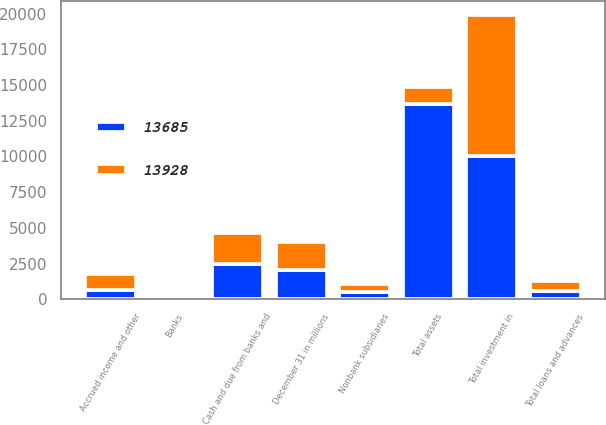Convert chart. <chart><loc_0><loc_0><loc_500><loc_500><stacked_bar_chart><ecel><fcel>December 31 in millions<fcel>Cash and due from banks and<fcel>Banks<fcel>Nonbank subsidiaries<fcel>Total loans and advances<fcel>Total investment in<fcel>Accrued income and other<fcel>Total assets<nl><fcel>13685<fcel>2013<fcel>2453<fcel>90<fcel>482<fcel>572<fcel>10049<fcel>611<fcel>13685<nl><fcel>13928<fcel>2012<fcel>2206<fcel>90<fcel>619<fcel>709<fcel>9862<fcel>1151<fcel>1151<nl></chart> 